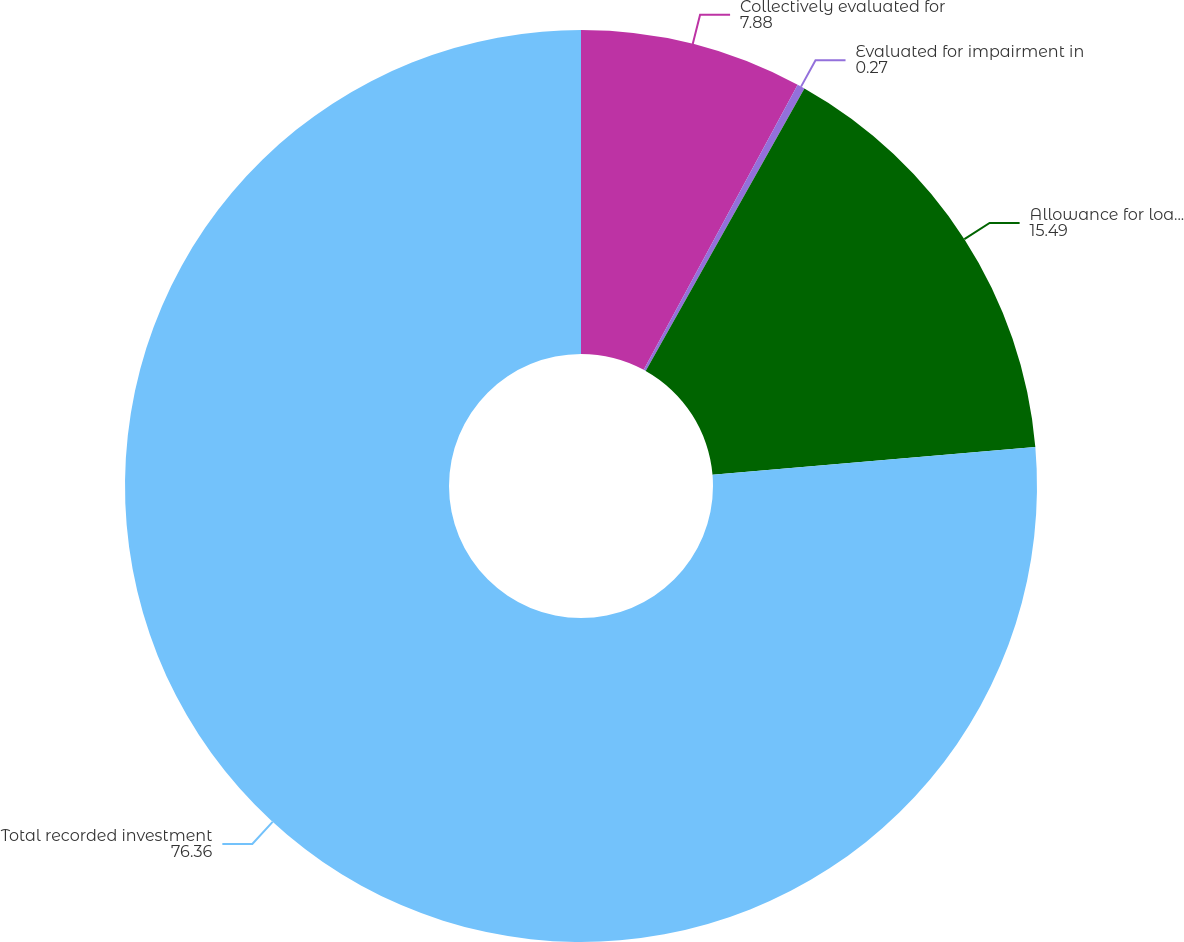Convert chart to OTSL. <chart><loc_0><loc_0><loc_500><loc_500><pie_chart><fcel>Collectively evaluated for<fcel>Evaluated for impairment in<fcel>Allowance for loan losses<fcel>Total recorded investment<nl><fcel>7.88%<fcel>0.27%<fcel>15.49%<fcel>76.36%<nl></chart> 